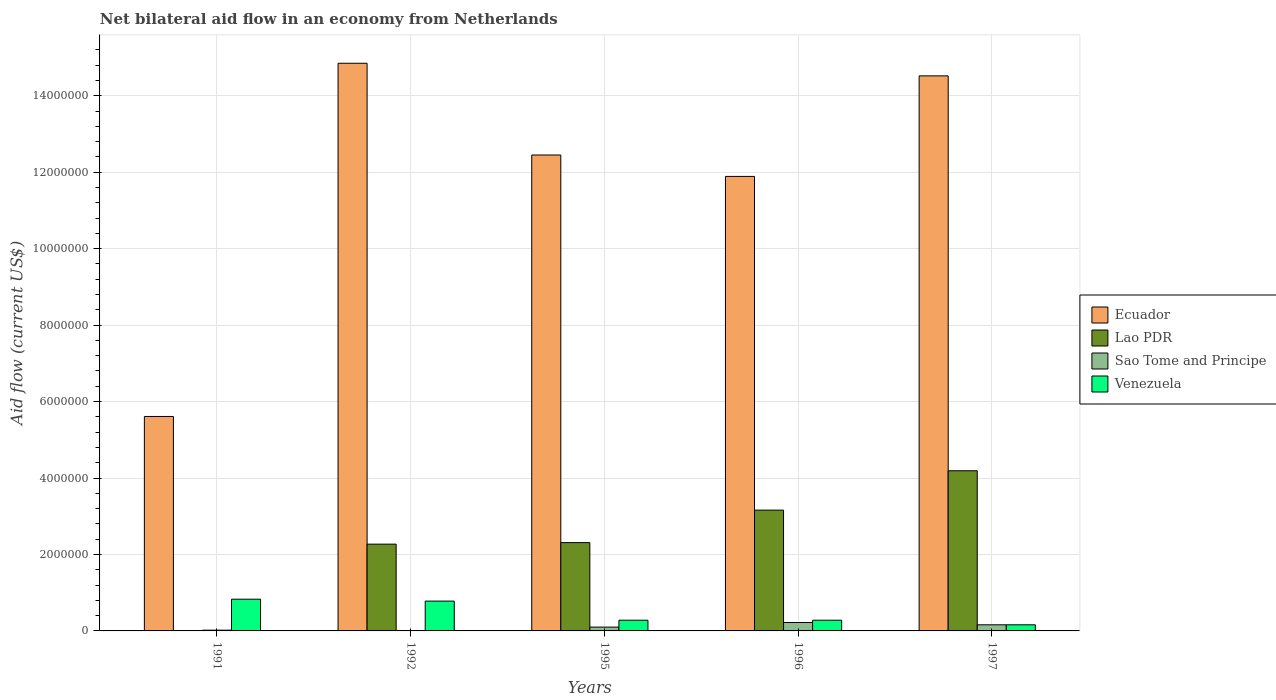Are the number of bars on each tick of the X-axis equal?
Provide a succinct answer. Yes. How many bars are there on the 4th tick from the right?
Make the answer very short. 4. What is the net bilateral aid flow in Sao Tome and Principe in 1996?
Give a very brief answer. 2.20e+05. Across all years, what is the maximum net bilateral aid flow in Venezuela?
Provide a short and direct response. 8.30e+05. In which year was the net bilateral aid flow in Sao Tome and Principe minimum?
Offer a very short reply. 1992. What is the total net bilateral aid flow in Sao Tome and Principe in the graph?
Keep it short and to the point. 5.10e+05. What is the difference between the net bilateral aid flow in Venezuela in 1991 and that in 1997?
Keep it short and to the point. 6.70e+05. What is the difference between the net bilateral aid flow in Sao Tome and Principe in 1992 and the net bilateral aid flow in Ecuador in 1995?
Your answer should be very brief. -1.24e+07. What is the average net bilateral aid flow in Lao PDR per year?
Your answer should be very brief. 2.39e+06. In the year 1992, what is the difference between the net bilateral aid flow in Ecuador and net bilateral aid flow in Venezuela?
Your answer should be compact. 1.41e+07. What is the ratio of the net bilateral aid flow in Lao PDR in 1991 to that in 1997?
Keep it short and to the point. 0. Is the net bilateral aid flow in Sao Tome and Principe in 1996 less than that in 1997?
Offer a terse response. No. Is the difference between the net bilateral aid flow in Ecuador in 1992 and 1996 greater than the difference between the net bilateral aid flow in Venezuela in 1992 and 1996?
Provide a short and direct response. Yes. What is the difference between the highest and the second highest net bilateral aid flow in Lao PDR?
Your answer should be compact. 1.03e+06. What is the difference between the highest and the lowest net bilateral aid flow in Sao Tome and Principe?
Give a very brief answer. 2.10e+05. In how many years, is the net bilateral aid flow in Venezuela greater than the average net bilateral aid flow in Venezuela taken over all years?
Your response must be concise. 2. Is the sum of the net bilateral aid flow in Lao PDR in 1991 and 1996 greater than the maximum net bilateral aid flow in Sao Tome and Principe across all years?
Give a very brief answer. Yes. Is it the case that in every year, the sum of the net bilateral aid flow in Lao PDR and net bilateral aid flow in Sao Tome and Principe is greater than the sum of net bilateral aid flow in Venezuela and net bilateral aid flow in Ecuador?
Your answer should be compact. No. What does the 1st bar from the left in 1997 represents?
Keep it short and to the point. Ecuador. What does the 3rd bar from the right in 1996 represents?
Offer a very short reply. Lao PDR. How many years are there in the graph?
Your answer should be very brief. 5. Are the values on the major ticks of Y-axis written in scientific E-notation?
Your answer should be compact. No. Does the graph contain grids?
Make the answer very short. Yes. Where does the legend appear in the graph?
Give a very brief answer. Center right. How are the legend labels stacked?
Offer a very short reply. Vertical. What is the title of the graph?
Provide a succinct answer. Net bilateral aid flow in an economy from Netherlands. Does "Faeroe Islands" appear as one of the legend labels in the graph?
Your answer should be very brief. No. What is the label or title of the Y-axis?
Your answer should be compact. Aid flow (current US$). What is the Aid flow (current US$) in Ecuador in 1991?
Provide a succinct answer. 5.61e+06. What is the Aid flow (current US$) of Venezuela in 1991?
Your response must be concise. 8.30e+05. What is the Aid flow (current US$) of Ecuador in 1992?
Provide a short and direct response. 1.48e+07. What is the Aid flow (current US$) in Lao PDR in 1992?
Offer a very short reply. 2.27e+06. What is the Aid flow (current US$) of Sao Tome and Principe in 1992?
Keep it short and to the point. 10000. What is the Aid flow (current US$) in Venezuela in 1992?
Offer a very short reply. 7.80e+05. What is the Aid flow (current US$) of Ecuador in 1995?
Your answer should be compact. 1.24e+07. What is the Aid flow (current US$) in Lao PDR in 1995?
Provide a short and direct response. 2.31e+06. What is the Aid flow (current US$) of Venezuela in 1995?
Your answer should be compact. 2.80e+05. What is the Aid flow (current US$) of Ecuador in 1996?
Offer a terse response. 1.19e+07. What is the Aid flow (current US$) of Lao PDR in 1996?
Provide a succinct answer. 3.16e+06. What is the Aid flow (current US$) of Ecuador in 1997?
Provide a succinct answer. 1.45e+07. What is the Aid flow (current US$) in Lao PDR in 1997?
Offer a very short reply. 4.19e+06. What is the Aid flow (current US$) of Sao Tome and Principe in 1997?
Provide a short and direct response. 1.60e+05. What is the Aid flow (current US$) of Venezuela in 1997?
Your answer should be very brief. 1.60e+05. Across all years, what is the maximum Aid flow (current US$) in Ecuador?
Provide a short and direct response. 1.48e+07. Across all years, what is the maximum Aid flow (current US$) in Lao PDR?
Your answer should be very brief. 4.19e+06. Across all years, what is the maximum Aid flow (current US$) of Sao Tome and Principe?
Your response must be concise. 2.20e+05. Across all years, what is the maximum Aid flow (current US$) in Venezuela?
Offer a very short reply. 8.30e+05. Across all years, what is the minimum Aid flow (current US$) of Ecuador?
Keep it short and to the point. 5.61e+06. Across all years, what is the minimum Aid flow (current US$) of Sao Tome and Principe?
Provide a short and direct response. 10000. Across all years, what is the minimum Aid flow (current US$) in Venezuela?
Your answer should be very brief. 1.60e+05. What is the total Aid flow (current US$) in Ecuador in the graph?
Give a very brief answer. 5.93e+07. What is the total Aid flow (current US$) of Lao PDR in the graph?
Your answer should be very brief. 1.19e+07. What is the total Aid flow (current US$) in Sao Tome and Principe in the graph?
Make the answer very short. 5.10e+05. What is the total Aid flow (current US$) of Venezuela in the graph?
Your answer should be compact. 2.33e+06. What is the difference between the Aid flow (current US$) in Ecuador in 1991 and that in 1992?
Give a very brief answer. -9.24e+06. What is the difference between the Aid flow (current US$) in Lao PDR in 1991 and that in 1992?
Provide a succinct answer. -2.26e+06. What is the difference between the Aid flow (current US$) of Ecuador in 1991 and that in 1995?
Ensure brevity in your answer.  -6.84e+06. What is the difference between the Aid flow (current US$) in Lao PDR in 1991 and that in 1995?
Provide a short and direct response. -2.30e+06. What is the difference between the Aid flow (current US$) of Ecuador in 1991 and that in 1996?
Offer a very short reply. -6.28e+06. What is the difference between the Aid flow (current US$) of Lao PDR in 1991 and that in 1996?
Provide a succinct answer. -3.15e+06. What is the difference between the Aid flow (current US$) of Sao Tome and Principe in 1991 and that in 1996?
Your answer should be compact. -2.00e+05. What is the difference between the Aid flow (current US$) of Venezuela in 1991 and that in 1996?
Ensure brevity in your answer.  5.50e+05. What is the difference between the Aid flow (current US$) of Ecuador in 1991 and that in 1997?
Make the answer very short. -8.91e+06. What is the difference between the Aid flow (current US$) in Lao PDR in 1991 and that in 1997?
Give a very brief answer. -4.18e+06. What is the difference between the Aid flow (current US$) in Sao Tome and Principe in 1991 and that in 1997?
Ensure brevity in your answer.  -1.40e+05. What is the difference between the Aid flow (current US$) in Venezuela in 1991 and that in 1997?
Make the answer very short. 6.70e+05. What is the difference between the Aid flow (current US$) of Ecuador in 1992 and that in 1995?
Provide a short and direct response. 2.40e+06. What is the difference between the Aid flow (current US$) of Lao PDR in 1992 and that in 1995?
Your answer should be compact. -4.00e+04. What is the difference between the Aid flow (current US$) in Sao Tome and Principe in 1992 and that in 1995?
Your answer should be compact. -9.00e+04. What is the difference between the Aid flow (current US$) in Ecuador in 1992 and that in 1996?
Your answer should be compact. 2.96e+06. What is the difference between the Aid flow (current US$) of Lao PDR in 1992 and that in 1996?
Provide a short and direct response. -8.90e+05. What is the difference between the Aid flow (current US$) of Sao Tome and Principe in 1992 and that in 1996?
Your response must be concise. -2.10e+05. What is the difference between the Aid flow (current US$) in Lao PDR in 1992 and that in 1997?
Your answer should be very brief. -1.92e+06. What is the difference between the Aid flow (current US$) in Venezuela in 1992 and that in 1997?
Provide a succinct answer. 6.20e+05. What is the difference between the Aid flow (current US$) in Ecuador in 1995 and that in 1996?
Provide a succinct answer. 5.60e+05. What is the difference between the Aid flow (current US$) in Lao PDR in 1995 and that in 1996?
Provide a succinct answer. -8.50e+05. What is the difference between the Aid flow (current US$) of Venezuela in 1995 and that in 1996?
Your answer should be compact. 0. What is the difference between the Aid flow (current US$) of Ecuador in 1995 and that in 1997?
Your answer should be compact. -2.07e+06. What is the difference between the Aid flow (current US$) of Lao PDR in 1995 and that in 1997?
Ensure brevity in your answer.  -1.88e+06. What is the difference between the Aid flow (current US$) in Sao Tome and Principe in 1995 and that in 1997?
Offer a very short reply. -6.00e+04. What is the difference between the Aid flow (current US$) in Ecuador in 1996 and that in 1997?
Ensure brevity in your answer.  -2.63e+06. What is the difference between the Aid flow (current US$) of Lao PDR in 1996 and that in 1997?
Make the answer very short. -1.03e+06. What is the difference between the Aid flow (current US$) of Sao Tome and Principe in 1996 and that in 1997?
Your answer should be compact. 6.00e+04. What is the difference between the Aid flow (current US$) in Ecuador in 1991 and the Aid flow (current US$) in Lao PDR in 1992?
Ensure brevity in your answer.  3.34e+06. What is the difference between the Aid flow (current US$) in Ecuador in 1991 and the Aid flow (current US$) in Sao Tome and Principe in 1992?
Keep it short and to the point. 5.60e+06. What is the difference between the Aid flow (current US$) of Ecuador in 1991 and the Aid flow (current US$) of Venezuela in 1992?
Provide a succinct answer. 4.83e+06. What is the difference between the Aid flow (current US$) of Lao PDR in 1991 and the Aid flow (current US$) of Sao Tome and Principe in 1992?
Offer a very short reply. 0. What is the difference between the Aid flow (current US$) in Lao PDR in 1991 and the Aid flow (current US$) in Venezuela in 1992?
Make the answer very short. -7.70e+05. What is the difference between the Aid flow (current US$) of Sao Tome and Principe in 1991 and the Aid flow (current US$) of Venezuela in 1992?
Provide a short and direct response. -7.60e+05. What is the difference between the Aid flow (current US$) in Ecuador in 1991 and the Aid flow (current US$) in Lao PDR in 1995?
Provide a succinct answer. 3.30e+06. What is the difference between the Aid flow (current US$) of Ecuador in 1991 and the Aid flow (current US$) of Sao Tome and Principe in 1995?
Your response must be concise. 5.51e+06. What is the difference between the Aid flow (current US$) in Ecuador in 1991 and the Aid flow (current US$) in Venezuela in 1995?
Your answer should be compact. 5.33e+06. What is the difference between the Aid flow (current US$) of Lao PDR in 1991 and the Aid flow (current US$) of Venezuela in 1995?
Offer a terse response. -2.70e+05. What is the difference between the Aid flow (current US$) in Sao Tome and Principe in 1991 and the Aid flow (current US$) in Venezuela in 1995?
Provide a succinct answer. -2.60e+05. What is the difference between the Aid flow (current US$) in Ecuador in 1991 and the Aid flow (current US$) in Lao PDR in 1996?
Make the answer very short. 2.45e+06. What is the difference between the Aid flow (current US$) in Ecuador in 1991 and the Aid flow (current US$) in Sao Tome and Principe in 1996?
Keep it short and to the point. 5.39e+06. What is the difference between the Aid flow (current US$) of Ecuador in 1991 and the Aid flow (current US$) of Venezuela in 1996?
Your answer should be compact. 5.33e+06. What is the difference between the Aid flow (current US$) of Ecuador in 1991 and the Aid flow (current US$) of Lao PDR in 1997?
Your answer should be compact. 1.42e+06. What is the difference between the Aid flow (current US$) in Ecuador in 1991 and the Aid flow (current US$) in Sao Tome and Principe in 1997?
Offer a very short reply. 5.45e+06. What is the difference between the Aid flow (current US$) in Ecuador in 1991 and the Aid flow (current US$) in Venezuela in 1997?
Make the answer very short. 5.45e+06. What is the difference between the Aid flow (current US$) of Lao PDR in 1991 and the Aid flow (current US$) of Venezuela in 1997?
Offer a terse response. -1.50e+05. What is the difference between the Aid flow (current US$) of Sao Tome and Principe in 1991 and the Aid flow (current US$) of Venezuela in 1997?
Provide a succinct answer. -1.40e+05. What is the difference between the Aid flow (current US$) of Ecuador in 1992 and the Aid flow (current US$) of Lao PDR in 1995?
Keep it short and to the point. 1.25e+07. What is the difference between the Aid flow (current US$) in Ecuador in 1992 and the Aid flow (current US$) in Sao Tome and Principe in 1995?
Your response must be concise. 1.48e+07. What is the difference between the Aid flow (current US$) of Ecuador in 1992 and the Aid flow (current US$) of Venezuela in 1995?
Make the answer very short. 1.46e+07. What is the difference between the Aid flow (current US$) in Lao PDR in 1992 and the Aid flow (current US$) in Sao Tome and Principe in 1995?
Your answer should be very brief. 2.17e+06. What is the difference between the Aid flow (current US$) in Lao PDR in 1992 and the Aid flow (current US$) in Venezuela in 1995?
Offer a terse response. 1.99e+06. What is the difference between the Aid flow (current US$) in Ecuador in 1992 and the Aid flow (current US$) in Lao PDR in 1996?
Make the answer very short. 1.17e+07. What is the difference between the Aid flow (current US$) of Ecuador in 1992 and the Aid flow (current US$) of Sao Tome and Principe in 1996?
Make the answer very short. 1.46e+07. What is the difference between the Aid flow (current US$) in Ecuador in 1992 and the Aid flow (current US$) in Venezuela in 1996?
Offer a terse response. 1.46e+07. What is the difference between the Aid flow (current US$) of Lao PDR in 1992 and the Aid flow (current US$) of Sao Tome and Principe in 1996?
Offer a terse response. 2.05e+06. What is the difference between the Aid flow (current US$) in Lao PDR in 1992 and the Aid flow (current US$) in Venezuela in 1996?
Your answer should be very brief. 1.99e+06. What is the difference between the Aid flow (current US$) of Sao Tome and Principe in 1992 and the Aid flow (current US$) of Venezuela in 1996?
Give a very brief answer. -2.70e+05. What is the difference between the Aid flow (current US$) in Ecuador in 1992 and the Aid flow (current US$) in Lao PDR in 1997?
Keep it short and to the point. 1.07e+07. What is the difference between the Aid flow (current US$) of Ecuador in 1992 and the Aid flow (current US$) of Sao Tome and Principe in 1997?
Keep it short and to the point. 1.47e+07. What is the difference between the Aid flow (current US$) in Ecuador in 1992 and the Aid flow (current US$) in Venezuela in 1997?
Your answer should be compact. 1.47e+07. What is the difference between the Aid flow (current US$) of Lao PDR in 1992 and the Aid flow (current US$) of Sao Tome and Principe in 1997?
Provide a succinct answer. 2.11e+06. What is the difference between the Aid flow (current US$) in Lao PDR in 1992 and the Aid flow (current US$) in Venezuela in 1997?
Provide a short and direct response. 2.11e+06. What is the difference between the Aid flow (current US$) of Ecuador in 1995 and the Aid flow (current US$) of Lao PDR in 1996?
Provide a succinct answer. 9.29e+06. What is the difference between the Aid flow (current US$) of Ecuador in 1995 and the Aid flow (current US$) of Sao Tome and Principe in 1996?
Offer a very short reply. 1.22e+07. What is the difference between the Aid flow (current US$) of Ecuador in 1995 and the Aid flow (current US$) of Venezuela in 1996?
Make the answer very short. 1.22e+07. What is the difference between the Aid flow (current US$) in Lao PDR in 1995 and the Aid flow (current US$) in Sao Tome and Principe in 1996?
Keep it short and to the point. 2.09e+06. What is the difference between the Aid flow (current US$) in Lao PDR in 1995 and the Aid flow (current US$) in Venezuela in 1996?
Your answer should be very brief. 2.03e+06. What is the difference between the Aid flow (current US$) in Ecuador in 1995 and the Aid flow (current US$) in Lao PDR in 1997?
Offer a very short reply. 8.26e+06. What is the difference between the Aid flow (current US$) of Ecuador in 1995 and the Aid flow (current US$) of Sao Tome and Principe in 1997?
Make the answer very short. 1.23e+07. What is the difference between the Aid flow (current US$) of Ecuador in 1995 and the Aid flow (current US$) of Venezuela in 1997?
Provide a succinct answer. 1.23e+07. What is the difference between the Aid flow (current US$) of Lao PDR in 1995 and the Aid flow (current US$) of Sao Tome and Principe in 1997?
Offer a very short reply. 2.15e+06. What is the difference between the Aid flow (current US$) in Lao PDR in 1995 and the Aid flow (current US$) in Venezuela in 1997?
Your answer should be very brief. 2.15e+06. What is the difference between the Aid flow (current US$) in Ecuador in 1996 and the Aid flow (current US$) in Lao PDR in 1997?
Offer a terse response. 7.70e+06. What is the difference between the Aid flow (current US$) of Ecuador in 1996 and the Aid flow (current US$) of Sao Tome and Principe in 1997?
Offer a very short reply. 1.17e+07. What is the difference between the Aid flow (current US$) in Ecuador in 1996 and the Aid flow (current US$) in Venezuela in 1997?
Keep it short and to the point. 1.17e+07. What is the difference between the Aid flow (current US$) in Lao PDR in 1996 and the Aid flow (current US$) in Sao Tome and Principe in 1997?
Your answer should be very brief. 3.00e+06. What is the average Aid flow (current US$) of Ecuador per year?
Make the answer very short. 1.19e+07. What is the average Aid flow (current US$) of Lao PDR per year?
Make the answer very short. 2.39e+06. What is the average Aid flow (current US$) in Sao Tome and Principe per year?
Offer a terse response. 1.02e+05. What is the average Aid flow (current US$) in Venezuela per year?
Make the answer very short. 4.66e+05. In the year 1991, what is the difference between the Aid flow (current US$) in Ecuador and Aid flow (current US$) in Lao PDR?
Give a very brief answer. 5.60e+06. In the year 1991, what is the difference between the Aid flow (current US$) in Ecuador and Aid flow (current US$) in Sao Tome and Principe?
Offer a very short reply. 5.59e+06. In the year 1991, what is the difference between the Aid flow (current US$) in Ecuador and Aid flow (current US$) in Venezuela?
Give a very brief answer. 4.78e+06. In the year 1991, what is the difference between the Aid flow (current US$) of Lao PDR and Aid flow (current US$) of Venezuela?
Provide a succinct answer. -8.20e+05. In the year 1991, what is the difference between the Aid flow (current US$) in Sao Tome and Principe and Aid flow (current US$) in Venezuela?
Provide a short and direct response. -8.10e+05. In the year 1992, what is the difference between the Aid flow (current US$) of Ecuador and Aid flow (current US$) of Lao PDR?
Keep it short and to the point. 1.26e+07. In the year 1992, what is the difference between the Aid flow (current US$) of Ecuador and Aid flow (current US$) of Sao Tome and Principe?
Offer a very short reply. 1.48e+07. In the year 1992, what is the difference between the Aid flow (current US$) of Ecuador and Aid flow (current US$) of Venezuela?
Give a very brief answer. 1.41e+07. In the year 1992, what is the difference between the Aid flow (current US$) in Lao PDR and Aid flow (current US$) in Sao Tome and Principe?
Your response must be concise. 2.26e+06. In the year 1992, what is the difference between the Aid flow (current US$) in Lao PDR and Aid flow (current US$) in Venezuela?
Your answer should be very brief. 1.49e+06. In the year 1992, what is the difference between the Aid flow (current US$) in Sao Tome and Principe and Aid flow (current US$) in Venezuela?
Offer a very short reply. -7.70e+05. In the year 1995, what is the difference between the Aid flow (current US$) of Ecuador and Aid flow (current US$) of Lao PDR?
Ensure brevity in your answer.  1.01e+07. In the year 1995, what is the difference between the Aid flow (current US$) in Ecuador and Aid flow (current US$) in Sao Tome and Principe?
Your answer should be compact. 1.24e+07. In the year 1995, what is the difference between the Aid flow (current US$) of Ecuador and Aid flow (current US$) of Venezuela?
Your answer should be compact. 1.22e+07. In the year 1995, what is the difference between the Aid flow (current US$) of Lao PDR and Aid flow (current US$) of Sao Tome and Principe?
Offer a terse response. 2.21e+06. In the year 1995, what is the difference between the Aid flow (current US$) in Lao PDR and Aid flow (current US$) in Venezuela?
Provide a short and direct response. 2.03e+06. In the year 1995, what is the difference between the Aid flow (current US$) of Sao Tome and Principe and Aid flow (current US$) of Venezuela?
Offer a very short reply. -1.80e+05. In the year 1996, what is the difference between the Aid flow (current US$) in Ecuador and Aid flow (current US$) in Lao PDR?
Make the answer very short. 8.73e+06. In the year 1996, what is the difference between the Aid flow (current US$) in Ecuador and Aid flow (current US$) in Sao Tome and Principe?
Provide a short and direct response. 1.17e+07. In the year 1996, what is the difference between the Aid flow (current US$) in Ecuador and Aid flow (current US$) in Venezuela?
Give a very brief answer. 1.16e+07. In the year 1996, what is the difference between the Aid flow (current US$) of Lao PDR and Aid flow (current US$) of Sao Tome and Principe?
Ensure brevity in your answer.  2.94e+06. In the year 1996, what is the difference between the Aid flow (current US$) in Lao PDR and Aid flow (current US$) in Venezuela?
Your answer should be compact. 2.88e+06. In the year 1996, what is the difference between the Aid flow (current US$) in Sao Tome and Principe and Aid flow (current US$) in Venezuela?
Make the answer very short. -6.00e+04. In the year 1997, what is the difference between the Aid flow (current US$) in Ecuador and Aid flow (current US$) in Lao PDR?
Keep it short and to the point. 1.03e+07. In the year 1997, what is the difference between the Aid flow (current US$) in Ecuador and Aid flow (current US$) in Sao Tome and Principe?
Ensure brevity in your answer.  1.44e+07. In the year 1997, what is the difference between the Aid flow (current US$) in Ecuador and Aid flow (current US$) in Venezuela?
Provide a succinct answer. 1.44e+07. In the year 1997, what is the difference between the Aid flow (current US$) of Lao PDR and Aid flow (current US$) of Sao Tome and Principe?
Your response must be concise. 4.03e+06. In the year 1997, what is the difference between the Aid flow (current US$) in Lao PDR and Aid flow (current US$) in Venezuela?
Provide a short and direct response. 4.03e+06. What is the ratio of the Aid flow (current US$) in Ecuador in 1991 to that in 1992?
Offer a very short reply. 0.38. What is the ratio of the Aid flow (current US$) of Lao PDR in 1991 to that in 1992?
Give a very brief answer. 0. What is the ratio of the Aid flow (current US$) of Sao Tome and Principe in 1991 to that in 1992?
Provide a succinct answer. 2. What is the ratio of the Aid flow (current US$) in Venezuela in 1991 to that in 1992?
Ensure brevity in your answer.  1.06. What is the ratio of the Aid flow (current US$) in Ecuador in 1991 to that in 1995?
Keep it short and to the point. 0.45. What is the ratio of the Aid flow (current US$) of Lao PDR in 1991 to that in 1995?
Your response must be concise. 0. What is the ratio of the Aid flow (current US$) of Sao Tome and Principe in 1991 to that in 1995?
Provide a succinct answer. 0.2. What is the ratio of the Aid flow (current US$) of Venezuela in 1991 to that in 1995?
Your answer should be compact. 2.96. What is the ratio of the Aid flow (current US$) of Ecuador in 1991 to that in 1996?
Your response must be concise. 0.47. What is the ratio of the Aid flow (current US$) of Lao PDR in 1991 to that in 1996?
Give a very brief answer. 0. What is the ratio of the Aid flow (current US$) of Sao Tome and Principe in 1991 to that in 1996?
Offer a very short reply. 0.09. What is the ratio of the Aid flow (current US$) in Venezuela in 1991 to that in 1996?
Give a very brief answer. 2.96. What is the ratio of the Aid flow (current US$) of Ecuador in 1991 to that in 1997?
Offer a very short reply. 0.39. What is the ratio of the Aid flow (current US$) in Lao PDR in 1991 to that in 1997?
Offer a terse response. 0. What is the ratio of the Aid flow (current US$) in Sao Tome and Principe in 1991 to that in 1997?
Your answer should be compact. 0.12. What is the ratio of the Aid flow (current US$) of Venezuela in 1991 to that in 1997?
Provide a short and direct response. 5.19. What is the ratio of the Aid flow (current US$) of Ecuador in 1992 to that in 1995?
Your answer should be compact. 1.19. What is the ratio of the Aid flow (current US$) of Lao PDR in 1992 to that in 1995?
Ensure brevity in your answer.  0.98. What is the ratio of the Aid flow (current US$) in Sao Tome and Principe in 1992 to that in 1995?
Your response must be concise. 0.1. What is the ratio of the Aid flow (current US$) of Venezuela in 1992 to that in 1995?
Keep it short and to the point. 2.79. What is the ratio of the Aid flow (current US$) in Ecuador in 1992 to that in 1996?
Your response must be concise. 1.25. What is the ratio of the Aid flow (current US$) in Lao PDR in 1992 to that in 1996?
Your answer should be very brief. 0.72. What is the ratio of the Aid flow (current US$) of Sao Tome and Principe in 1992 to that in 1996?
Your response must be concise. 0.05. What is the ratio of the Aid flow (current US$) of Venezuela in 1992 to that in 1996?
Your response must be concise. 2.79. What is the ratio of the Aid flow (current US$) in Ecuador in 1992 to that in 1997?
Offer a terse response. 1.02. What is the ratio of the Aid flow (current US$) of Lao PDR in 1992 to that in 1997?
Offer a very short reply. 0.54. What is the ratio of the Aid flow (current US$) in Sao Tome and Principe in 1992 to that in 1997?
Ensure brevity in your answer.  0.06. What is the ratio of the Aid flow (current US$) of Venezuela in 1992 to that in 1997?
Your answer should be compact. 4.88. What is the ratio of the Aid flow (current US$) of Ecuador in 1995 to that in 1996?
Keep it short and to the point. 1.05. What is the ratio of the Aid flow (current US$) in Lao PDR in 1995 to that in 1996?
Offer a very short reply. 0.73. What is the ratio of the Aid flow (current US$) in Sao Tome and Principe in 1995 to that in 1996?
Your answer should be compact. 0.45. What is the ratio of the Aid flow (current US$) in Venezuela in 1995 to that in 1996?
Your answer should be very brief. 1. What is the ratio of the Aid flow (current US$) in Ecuador in 1995 to that in 1997?
Ensure brevity in your answer.  0.86. What is the ratio of the Aid flow (current US$) in Lao PDR in 1995 to that in 1997?
Provide a short and direct response. 0.55. What is the ratio of the Aid flow (current US$) in Ecuador in 1996 to that in 1997?
Keep it short and to the point. 0.82. What is the ratio of the Aid flow (current US$) in Lao PDR in 1996 to that in 1997?
Make the answer very short. 0.75. What is the ratio of the Aid flow (current US$) of Sao Tome and Principe in 1996 to that in 1997?
Give a very brief answer. 1.38. What is the ratio of the Aid flow (current US$) in Venezuela in 1996 to that in 1997?
Provide a succinct answer. 1.75. What is the difference between the highest and the second highest Aid flow (current US$) in Ecuador?
Offer a terse response. 3.30e+05. What is the difference between the highest and the second highest Aid flow (current US$) in Lao PDR?
Offer a terse response. 1.03e+06. What is the difference between the highest and the lowest Aid flow (current US$) in Ecuador?
Your answer should be compact. 9.24e+06. What is the difference between the highest and the lowest Aid flow (current US$) of Lao PDR?
Provide a short and direct response. 4.18e+06. What is the difference between the highest and the lowest Aid flow (current US$) of Venezuela?
Make the answer very short. 6.70e+05. 